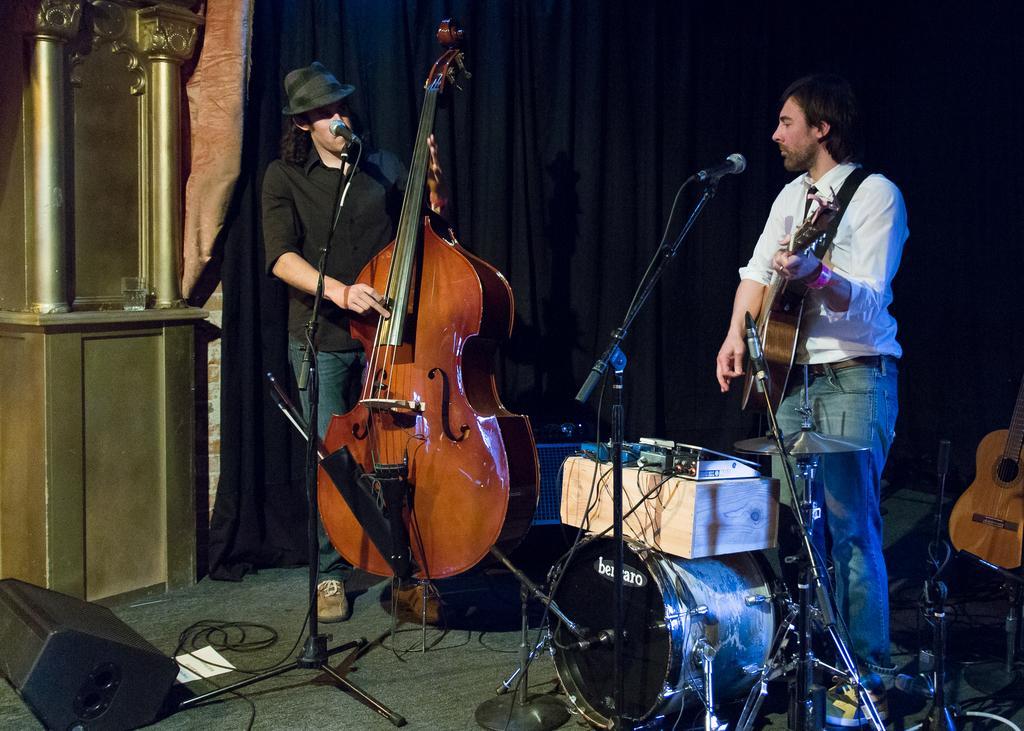Please provide a concise description of this image. In this picture there is a person who is standing at the left side of the image, he is playing the guitar and there is another person who is standing at the right side of the image, he is playing the guitar and singing in the mic, there is a speaker at the left side of the image and there is a black color curtain behind the people. 